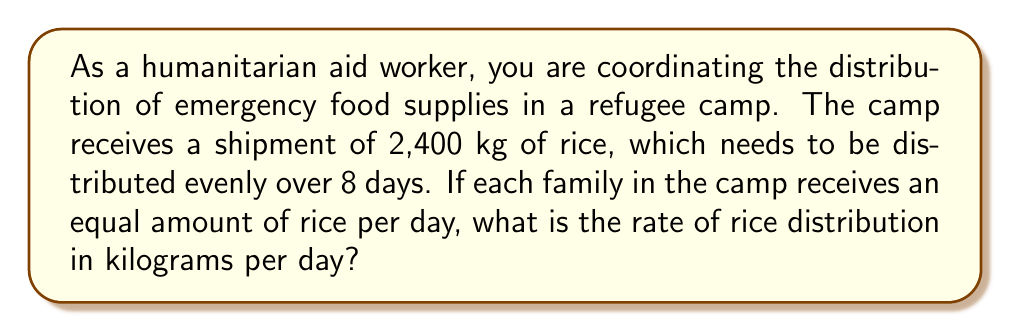Help me with this question. To solve this problem, we need to determine the rate of distribution, which is the amount of rice distributed per day. We can use the formula:

$$\text{Rate} = \frac{\text{Total amount}}{\text{Time}}$$

Given:
- Total amount of rice: 2,400 kg
- Distribution period: 8 days

Let's substitute these values into the formula:

$$\text{Rate} = \frac{2,400 \text{ kg}}{8 \text{ days}}$$

Now, we can perform the division:

$$\text{Rate} = 300 \text{ kg/day}$$

This means that 300 kg of rice will be distributed each day to ensure an even distribution over the 8-day period.
Answer: The rate of rice distribution is $300 \text{ kg/day}$. 